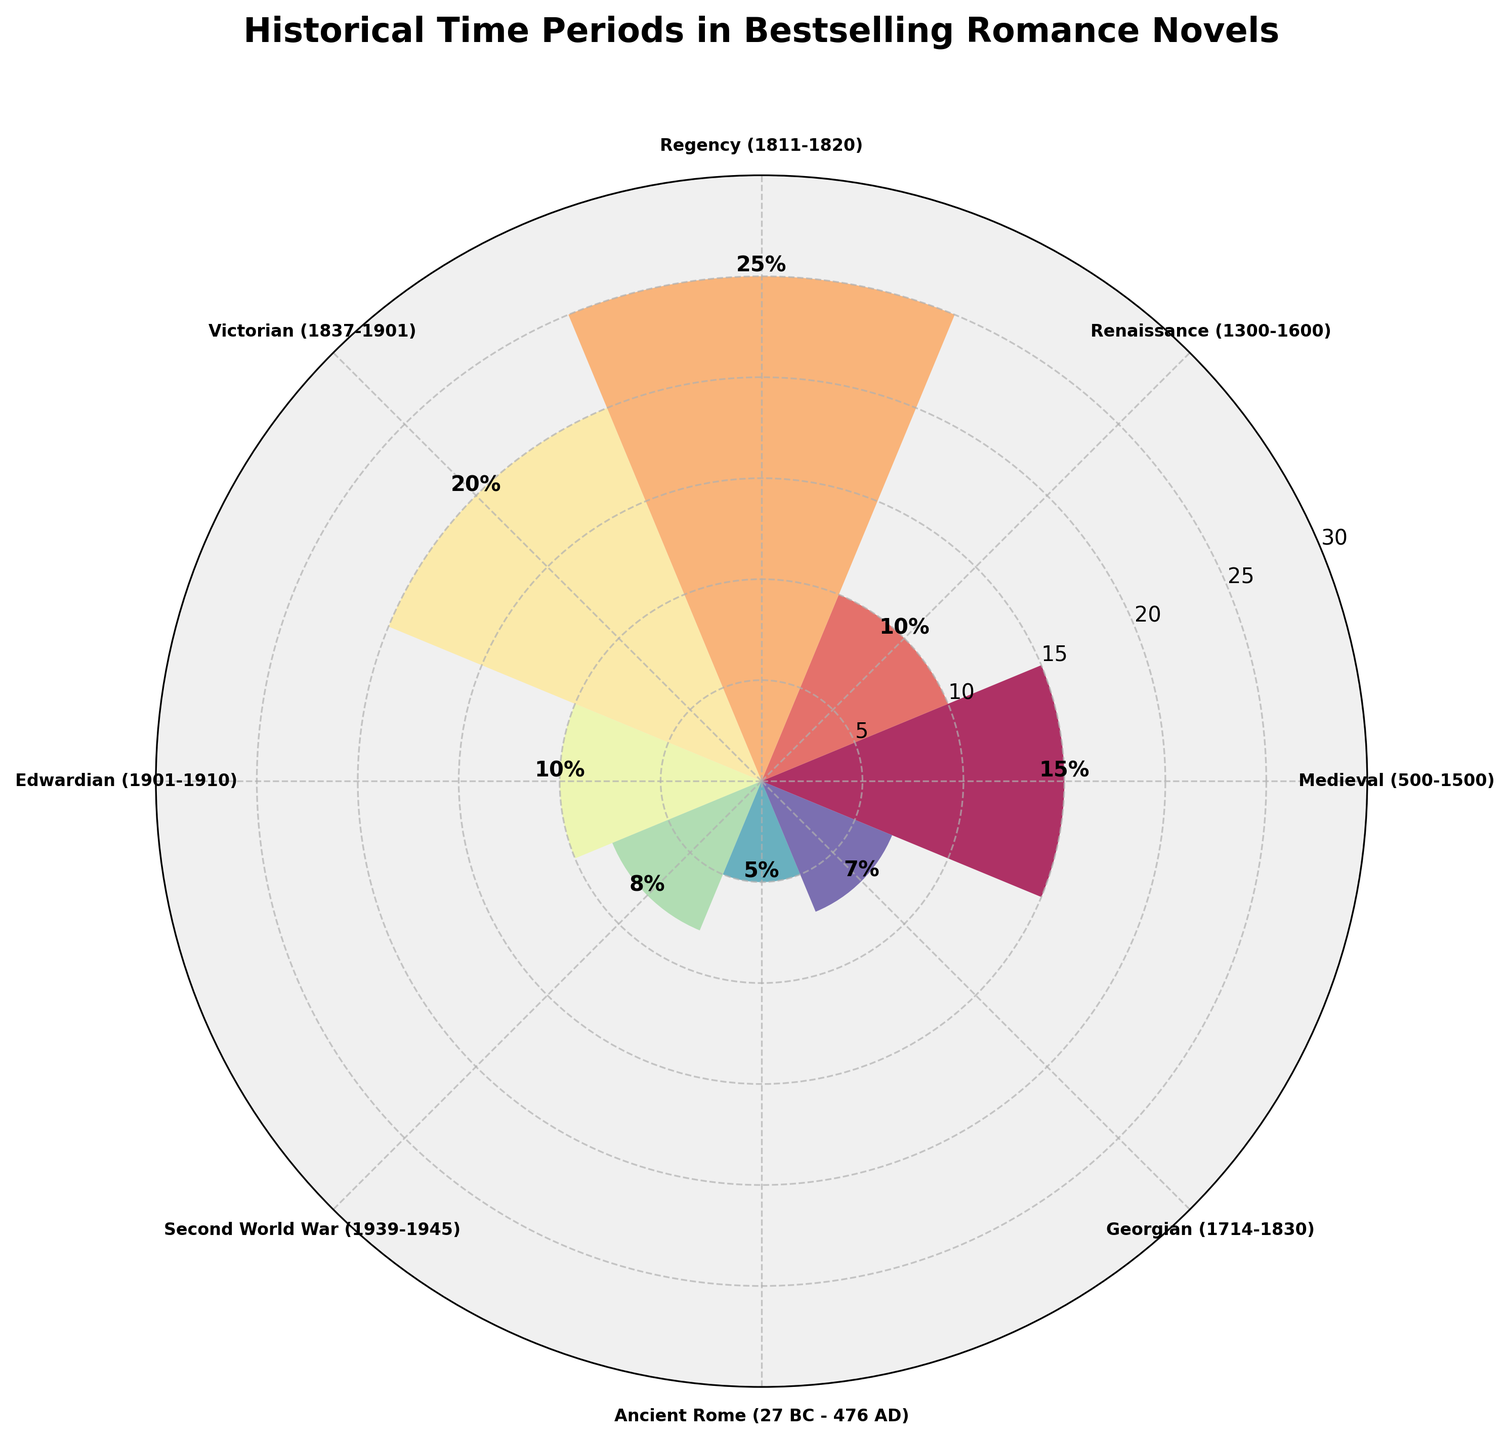What is the title of the figure? The title of the figure is displayed prominently at the top. It reads "Historical Time Periods in Bestselling Romance Novels."
Answer: Historical Time Periods in Bestselling Romance Novels What historical period has the highest percentage? By observing the lengths of the bars, the Regency period stands out with the longest bar. The value labeled on it confirms it is the highest.
Answer: Regency Which two periods have the lowest percentages? The shortest bars can easily be identified as belonging to Ancient Rome and the Second World War periods. The values on these bars (5% and 8% respectively) confirm they have the lowest percentages.
Answer: Ancient Rome and Second World War What is the combined percentage of the Edwardian and Victorian periods? The heights of the bars for the Edwardian and Victorian periods are labeled with 10% and 20% respectively. Their combined percentage is the sum of these two values.
Answer: 30% How many historical periods are featured in the figure? By counting the labeled wedges (bars) around the circular plot, we see there are eight distinct periods.
Answer: Eight Which period has a higher percentage, the Renaissance or the Georgian? The bars corresponding to the Renaissance and Georgian periods can be compared directly in length and the values. The Renaissance bar is labeled as 10% and the Georgian as 7%.
Answer: Renaissance How does the percentage of Medieval novels compare to Regency novels? The bars for the Medieval and Regency periods show different heights and values. The Medieval period is labeled as 15% and the Regency period as 25%, indicating the Regency period has a higher percentage.
Answer: The Regency period is higher Which period is more popular: Victorian or Medieval? Comparing the heights of the bars for the Victorian and Medieval periods, the Victorian bar is higher. Victorian is labeled 20% while Medieval is 15%.
Answer: Victorian What is the average percentage of the top three most popular historical periods? The top three most popular periods are identified by the longest bars: Regency (25%), Victorian (20%), and Medieval (15%). The average is calculated as (25% + 20% + 15%) / 3.
Answer: 20% What color is used for the Georgian period wedge? By inspecting the color coding of the plot, the Georgian period wedge can be identified. The bar labeled "Georgian" is colored, which is derived from the Spectral colormap, appearing closer to a lighter shade. The exact color is visually identifiable.
Answer: Light shade 